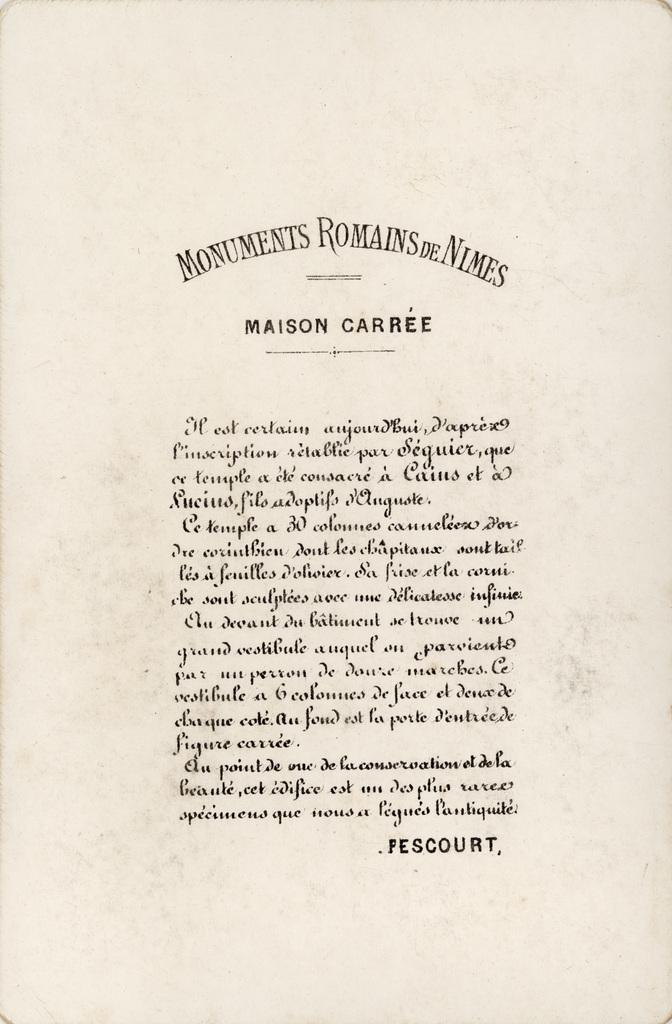What does the header say?
Your answer should be very brief. Monuments romains de nimes. 